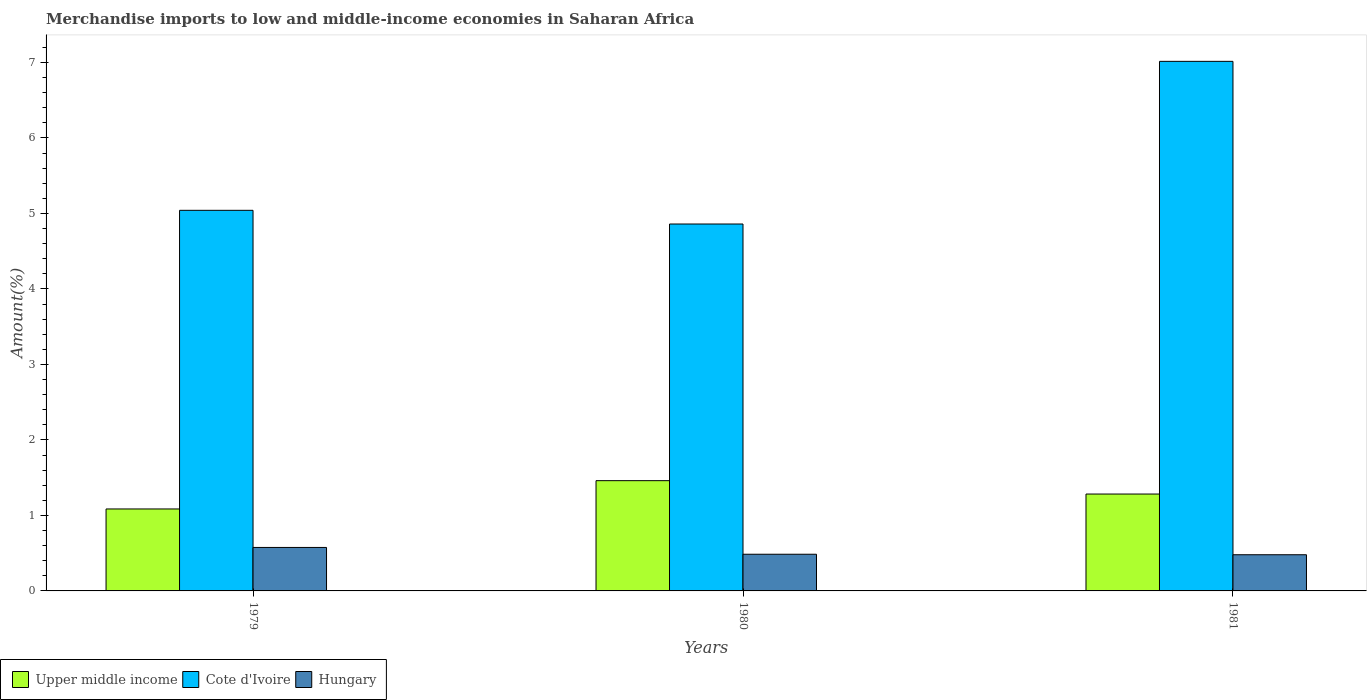How many different coloured bars are there?
Your answer should be compact. 3. How many groups of bars are there?
Your response must be concise. 3. Are the number of bars on each tick of the X-axis equal?
Make the answer very short. Yes. What is the label of the 1st group of bars from the left?
Provide a succinct answer. 1979. In how many cases, is the number of bars for a given year not equal to the number of legend labels?
Provide a succinct answer. 0. What is the percentage of amount earned from merchandise imports in Cote d'Ivoire in 1979?
Provide a short and direct response. 5.04. Across all years, what is the maximum percentage of amount earned from merchandise imports in Hungary?
Your answer should be compact. 0.58. Across all years, what is the minimum percentage of amount earned from merchandise imports in Upper middle income?
Make the answer very short. 1.09. In which year was the percentage of amount earned from merchandise imports in Upper middle income maximum?
Make the answer very short. 1980. In which year was the percentage of amount earned from merchandise imports in Hungary minimum?
Ensure brevity in your answer.  1981. What is the total percentage of amount earned from merchandise imports in Hungary in the graph?
Your response must be concise. 1.54. What is the difference between the percentage of amount earned from merchandise imports in Upper middle income in 1979 and that in 1981?
Provide a succinct answer. -0.2. What is the difference between the percentage of amount earned from merchandise imports in Upper middle income in 1981 and the percentage of amount earned from merchandise imports in Cote d'Ivoire in 1979?
Your answer should be very brief. -3.76. What is the average percentage of amount earned from merchandise imports in Upper middle income per year?
Make the answer very short. 1.28. In the year 1979, what is the difference between the percentage of amount earned from merchandise imports in Hungary and percentage of amount earned from merchandise imports in Cote d'Ivoire?
Provide a short and direct response. -4.47. In how many years, is the percentage of amount earned from merchandise imports in Cote d'Ivoire greater than 2.2 %?
Your response must be concise. 3. What is the ratio of the percentage of amount earned from merchandise imports in Cote d'Ivoire in 1979 to that in 1980?
Offer a terse response. 1.04. Is the percentage of amount earned from merchandise imports in Hungary in 1980 less than that in 1981?
Your answer should be compact. No. Is the difference between the percentage of amount earned from merchandise imports in Hungary in 1979 and 1981 greater than the difference between the percentage of amount earned from merchandise imports in Cote d'Ivoire in 1979 and 1981?
Your answer should be very brief. Yes. What is the difference between the highest and the second highest percentage of amount earned from merchandise imports in Hungary?
Provide a short and direct response. 0.09. What is the difference between the highest and the lowest percentage of amount earned from merchandise imports in Cote d'Ivoire?
Your answer should be very brief. 2.15. In how many years, is the percentage of amount earned from merchandise imports in Upper middle income greater than the average percentage of amount earned from merchandise imports in Upper middle income taken over all years?
Keep it short and to the point. 2. What does the 1st bar from the left in 1979 represents?
Make the answer very short. Upper middle income. What does the 1st bar from the right in 1979 represents?
Provide a succinct answer. Hungary. How many bars are there?
Make the answer very short. 9. How many years are there in the graph?
Provide a short and direct response. 3. Does the graph contain any zero values?
Provide a succinct answer. No. How many legend labels are there?
Make the answer very short. 3. How are the legend labels stacked?
Keep it short and to the point. Horizontal. What is the title of the graph?
Give a very brief answer. Merchandise imports to low and middle-income economies in Saharan Africa. Does "Macao" appear as one of the legend labels in the graph?
Offer a terse response. No. What is the label or title of the Y-axis?
Ensure brevity in your answer.  Amount(%). What is the Amount(%) in Upper middle income in 1979?
Provide a succinct answer. 1.09. What is the Amount(%) in Cote d'Ivoire in 1979?
Provide a short and direct response. 5.04. What is the Amount(%) of Hungary in 1979?
Offer a very short reply. 0.58. What is the Amount(%) in Upper middle income in 1980?
Your response must be concise. 1.46. What is the Amount(%) of Cote d'Ivoire in 1980?
Offer a terse response. 4.86. What is the Amount(%) in Hungary in 1980?
Your answer should be compact. 0.49. What is the Amount(%) of Upper middle income in 1981?
Provide a succinct answer. 1.28. What is the Amount(%) of Cote d'Ivoire in 1981?
Ensure brevity in your answer.  7.01. What is the Amount(%) of Hungary in 1981?
Ensure brevity in your answer.  0.48. Across all years, what is the maximum Amount(%) in Upper middle income?
Provide a succinct answer. 1.46. Across all years, what is the maximum Amount(%) of Cote d'Ivoire?
Your answer should be compact. 7.01. Across all years, what is the maximum Amount(%) of Hungary?
Make the answer very short. 0.58. Across all years, what is the minimum Amount(%) in Upper middle income?
Offer a terse response. 1.09. Across all years, what is the minimum Amount(%) in Cote d'Ivoire?
Your answer should be compact. 4.86. Across all years, what is the minimum Amount(%) of Hungary?
Offer a very short reply. 0.48. What is the total Amount(%) in Upper middle income in the graph?
Your answer should be compact. 3.83. What is the total Amount(%) in Cote d'Ivoire in the graph?
Give a very brief answer. 16.91. What is the total Amount(%) in Hungary in the graph?
Make the answer very short. 1.54. What is the difference between the Amount(%) in Upper middle income in 1979 and that in 1980?
Give a very brief answer. -0.37. What is the difference between the Amount(%) in Cote d'Ivoire in 1979 and that in 1980?
Your response must be concise. 0.18. What is the difference between the Amount(%) in Hungary in 1979 and that in 1980?
Your answer should be compact. 0.09. What is the difference between the Amount(%) in Upper middle income in 1979 and that in 1981?
Provide a succinct answer. -0.2. What is the difference between the Amount(%) in Cote d'Ivoire in 1979 and that in 1981?
Your response must be concise. -1.97. What is the difference between the Amount(%) in Hungary in 1979 and that in 1981?
Your answer should be very brief. 0.1. What is the difference between the Amount(%) in Upper middle income in 1980 and that in 1981?
Give a very brief answer. 0.18. What is the difference between the Amount(%) in Cote d'Ivoire in 1980 and that in 1981?
Give a very brief answer. -2.15. What is the difference between the Amount(%) in Hungary in 1980 and that in 1981?
Give a very brief answer. 0.01. What is the difference between the Amount(%) of Upper middle income in 1979 and the Amount(%) of Cote d'Ivoire in 1980?
Give a very brief answer. -3.77. What is the difference between the Amount(%) in Upper middle income in 1979 and the Amount(%) in Hungary in 1980?
Your answer should be compact. 0.6. What is the difference between the Amount(%) of Cote d'Ivoire in 1979 and the Amount(%) of Hungary in 1980?
Provide a short and direct response. 4.56. What is the difference between the Amount(%) in Upper middle income in 1979 and the Amount(%) in Cote d'Ivoire in 1981?
Provide a succinct answer. -5.93. What is the difference between the Amount(%) of Upper middle income in 1979 and the Amount(%) of Hungary in 1981?
Your answer should be very brief. 0.61. What is the difference between the Amount(%) of Cote d'Ivoire in 1979 and the Amount(%) of Hungary in 1981?
Offer a very short reply. 4.56. What is the difference between the Amount(%) of Upper middle income in 1980 and the Amount(%) of Cote d'Ivoire in 1981?
Offer a very short reply. -5.55. What is the difference between the Amount(%) in Upper middle income in 1980 and the Amount(%) in Hungary in 1981?
Your response must be concise. 0.98. What is the difference between the Amount(%) in Cote d'Ivoire in 1980 and the Amount(%) in Hungary in 1981?
Offer a terse response. 4.38. What is the average Amount(%) in Upper middle income per year?
Your answer should be compact. 1.28. What is the average Amount(%) of Cote d'Ivoire per year?
Your response must be concise. 5.64. What is the average Amount(%) of Hungary per year?
Offer a very short reply. 0.51. In the year 1979, what is the difference between the Amount(%) of Upper middle income and Amount(%) of Cote d'Ivoire?
Your response must be concise. -3.96. In the year 1979, what is the difference between the Amount(%) in Upper middle income and Amount(%) in Hungary?
Give a very brief answer. 0.51. In the year 1979, what is the difference between the Amount(%) in Cote d'Ivoire and Amount(%) in Hungary?
Offer a very short reply. 4.47. In the year 1980, what is the difference between the Amount(%) in Upper middle income and Amount(%) in Cote d'Ivoire?
Ensure brevity in your answer.  -3.4. In the year 1980, what is the difference between the Amount(%) in Upper middle income and Amount(%) in Hungary?
Your response must be concise. 0.97. In the year 1980, what is the difference between the Amount(%) in Cote d'Ivoire and Amount(%) in Hungary?
Keep it short and to the point. 4.37. In the year 1981, what is the difference between the Amount(%) of Upper middle income and Amount(%) of Cote d'Ivoire?
Your answer should be very brief. -5.73. In the year 1981, what is the difference between the Amount(%) in Upper middle income and Amount(%) in Hungary?
Offer a very short reply. 0.8. In the year 1981, what is the difference between the Amount(%) in Cote d'Ivoire and Amount(%) in Hungary?
Your response must be concise. 6.53. What is the ratio of the Amount(%) in Upper middle income in 1979 to that in 1980?
Keep it short and to the point. 0.74. What is the ratio of the Amount(%) in Cote d'Ivoire in 1979 to that in 1980?
Keep it short and to the point. 1.04. What is the ratio of the Amount(%) in Hungary in 1979 to that in 1980?
Keep it short and to the point. 1.19. What is the ratio of the Amount(%) of Upper middle income in 1979 to that in 1981?
Keep it short and to the point. 0.85. What is the ratio of the Amount(%) of Cote d'Ivoire in 1979 to that in 1981?
Your answer should be compact. 0.72. What is the ratio of the Amount(%) in Hungary in 1979 to that in 1981?
Provide a succinct answer. 1.2. What is the ratio of the Amount(%) in Upper middle income in 1980 to that in 1981?
Keep it short and to the point. 1.14. What is the ratio of the Amount(%) of Cote d'Ivoire in 1980 to that in 1981?
Keep it short and to the point. 0.69. What is the ratio of the Amount(%) of Hungary in 1980 to that in 1981?
Keep it short and to the point. 1.01. What is the difference between the highest and the second highest Amount(%) of Upper middle income?
Your response must be concise. 0.18. What is the difference between the highest and the second highest Amount(%) of Cote d'Ivoire?
Provide a short and direct response. 1.97. What is the difference between the highest and the second highest Amount(%) in Hungary?
Make the answer very short. 0.09. What is the difference between the highest and the lowest Amount(%) in Upper middle income?
Your answer should be compact. 0.37. What is the difference between the highest and the lowest Amount(%) of Cote d'Ivoire?
Keep it short and to the point. 2.15. What is the difference between the highest and the lowest Amount(%) of Hungary?
Give a very brief answer. 0.1. 